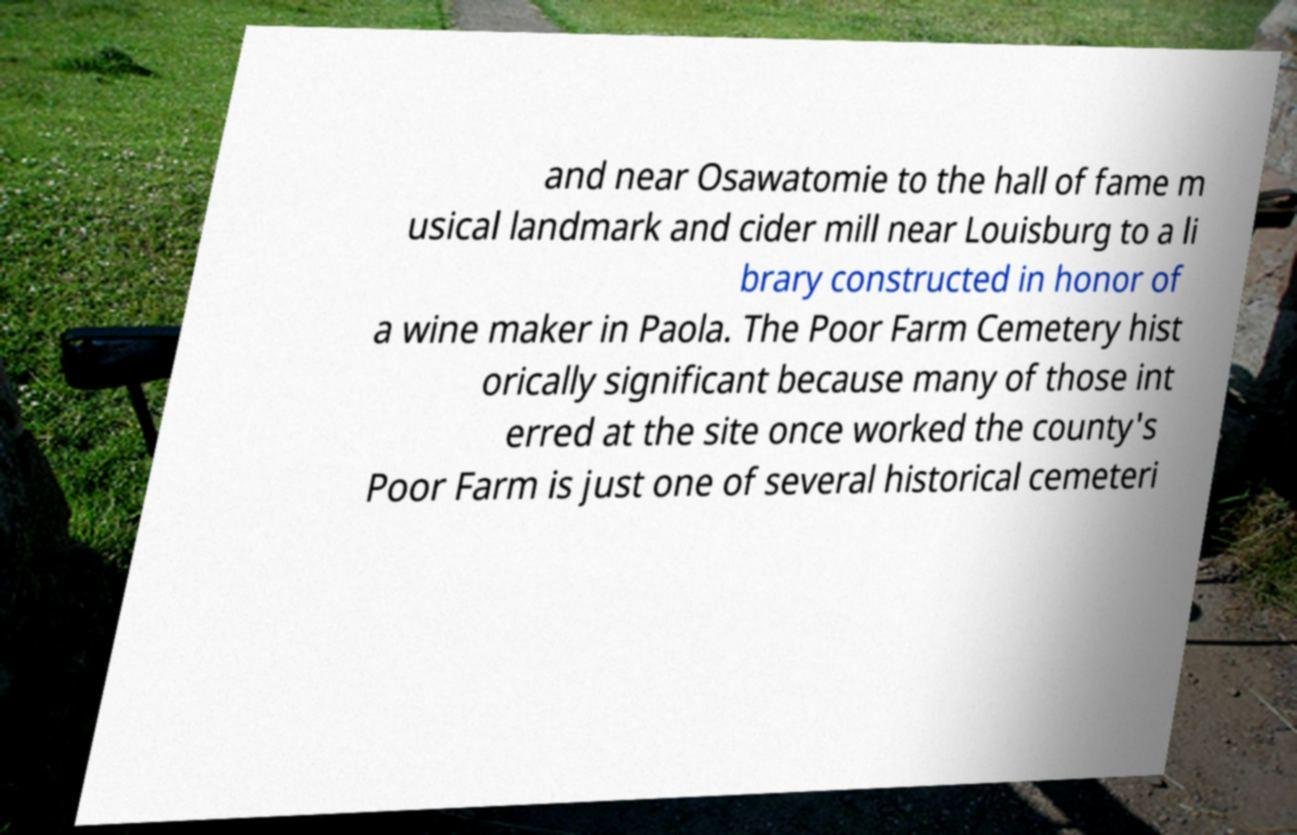Could you assist in decoding the text presented in this image and type it out clearly? and near Osawatomie to the hall of fame m usical landmark and cider mill near Louisburg to a li brary constructed in honor of a wine maker in Paola. The Poor Farm Cemetery hist orically significant because many of those int erred at the site once worked the county's Poor Farm is just one of several historical cemeteri 